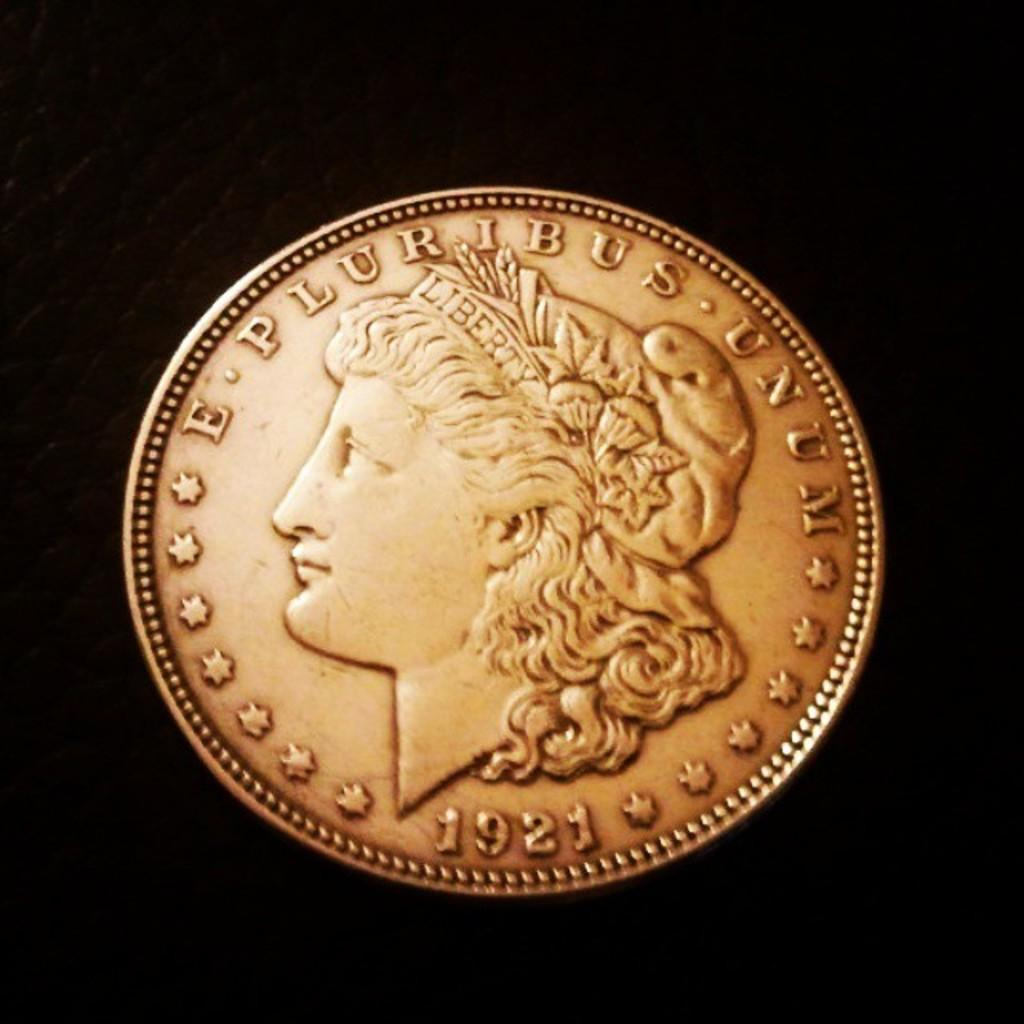<image>
Create a compact narrative representing the image presented. a bronze coin with words E Pluribus Unum and 1921 